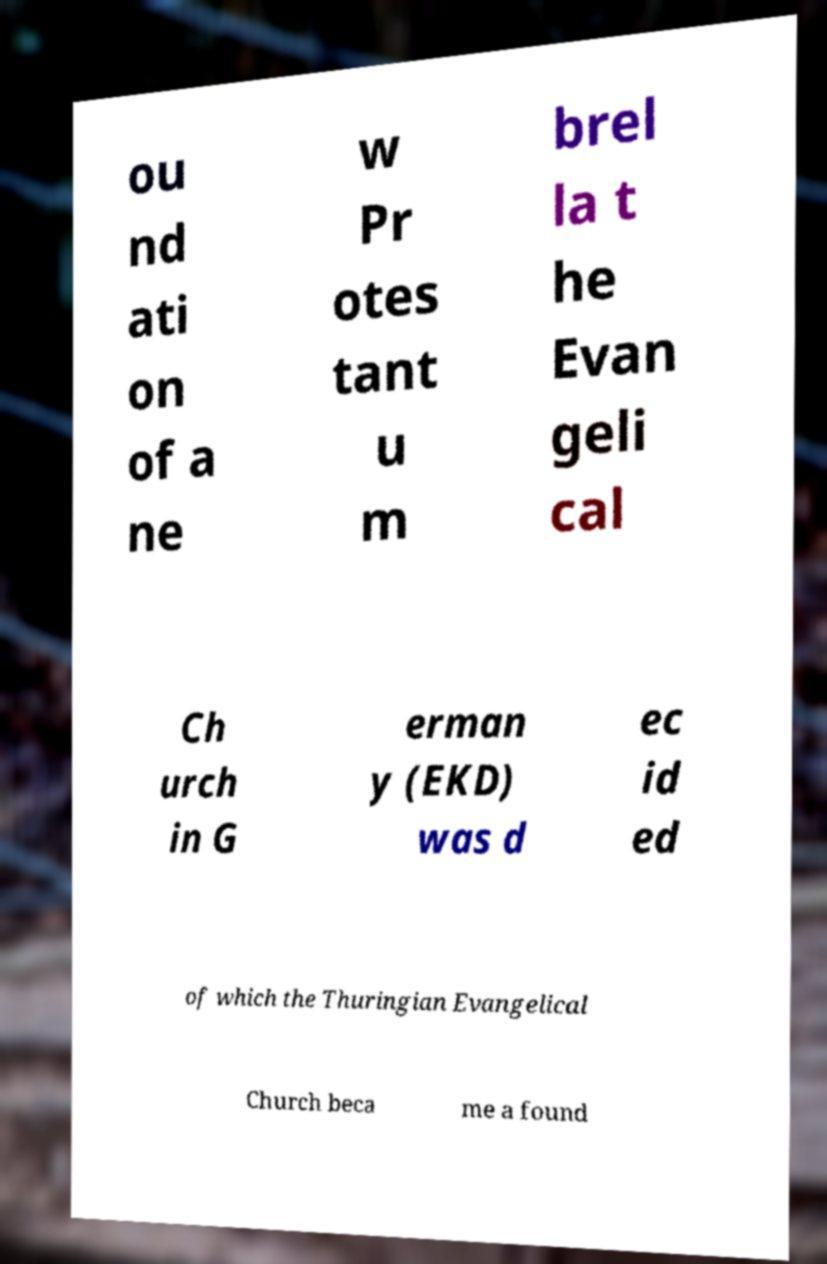Could you extract and type out the text from this image? ou nd ati on of a ne w Pr otes tant u m brel la t he Evan geli cal Ch urch in G erman y (EKD) was d ec id ed of which the Thuringian Evangelical Church beca me a found 